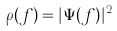<formula> <loc_0><loc_0><loc_500><loc_500>\rho ( f ) = | \Psi ( f ) | ^ { 2 }</formula> 